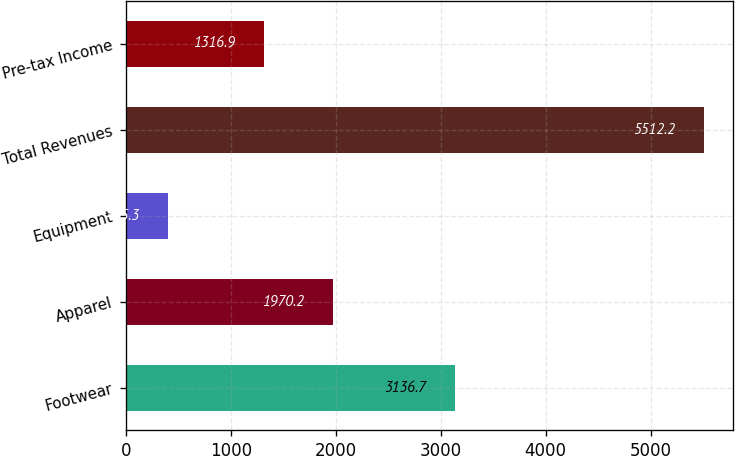Convert chart. <chart><loc_0><loc_0><loc_500><loc_500><bar_chart><fcel>Footwear<fcel>Apparel<fcel>Equipment<fcel>Total Revenues<fcel>Pre-tax Income<nl><fcel>3136.7<fcel>1970.2<fcel>405.3<fcel>5512.2<fcel>1316.9<nl></chart> 